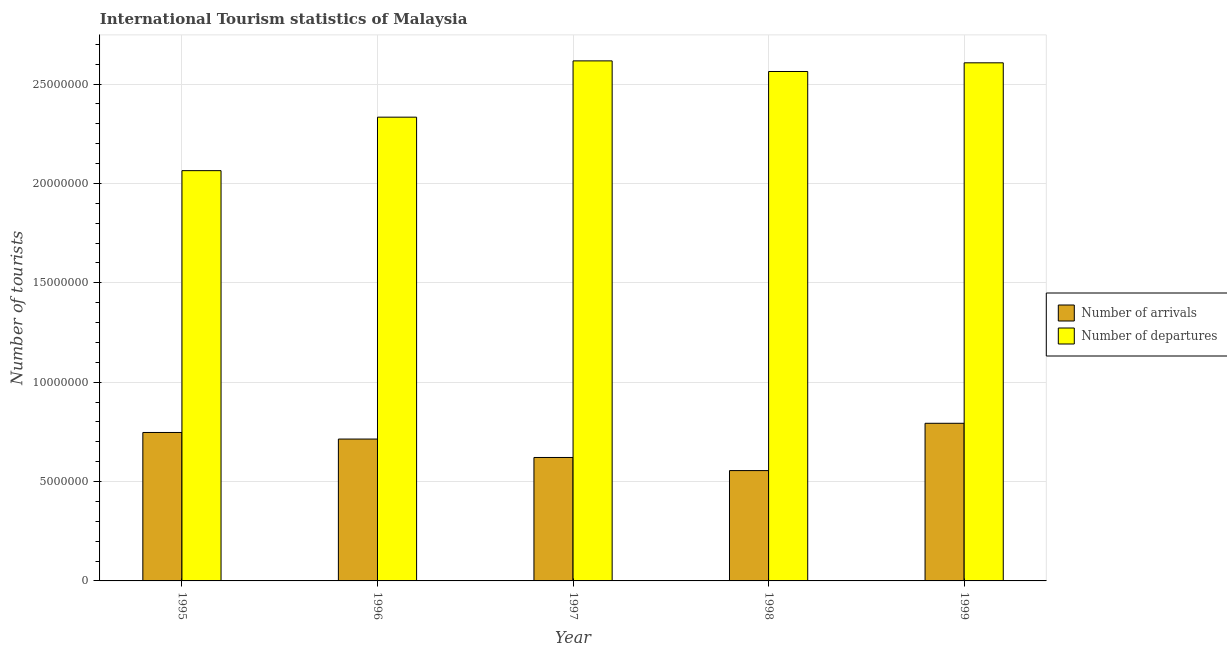How many different coloured bars are there?
Your answer should be very brief. 2. How many bars are there on the 4th tick from the right?
Provide a short and direct response. 2. What is the label of the 4th group of bars from the left?
Your response must be concise. 1998. In how many cases, is the number of bars for a given year not equal to the number of legend labels?
Give a very brief answer. 0. What is the number of tourist departures in 1996?
Your answer should be compact. 2.33e+07. Across all years, what is the maximum number of tourist departures?
Provide a short and direct response. 2.62e+07. Across all years, what is the minimum number of tourist arrivals?
Offer a terse response. 5.55e+06. What is the total number of tourist departures in the graph?
Give a very brief answer. 1.22e+08. What is the difference between the number of tourist departures in 1997 and that in 1998?
Your answer should be compact. 5.34e+05. What is the difference between the number of tourist arrivals in 1995 and the number of tourist departures in 1999?
Provide a succinct answer. -4.62e+05. What is the average number of tourist arrivals per year?
Your response must be concise. 6.86e+06. In the year 1999, what is the difference between the number of tourist arrivals and number of tourist departures?
Give a very brief answer. 0. In how many years, is the number of tourist arrivals greater than 15000000?
Your response must be concise. 0. What is the ratio of the number of tourist arrivals in 1995 to that in 1996?
Ensure brevity in your answer.  1.05. Is the difference between the number of tourist departures in 1995 and 1998 greater than the difference between the number of tourist arrivals in 1995 and 1998?
Give a very brief answer. No. What is the difference between the highest and the second highest number of tourist arrivals?
Offer a terse response. 4.62e+05. What is the difference between the highest and the lowest number of tourist arrivals?
Offer a terse response. 2.38e+06. Is the sum of the number of tourist departures in 1995 and 1998 greater than the maximum number of tourist arrivals across all years?
Provide a short and direct response. Yes. What does the 2nd bar from the left in 1996 represents?
Your answer should be compact. Number of departures. What does the 1st bar from the right in 1999 represents?
Keep it short and to the point. Number of departures. How many bars are there?
Your response must be concise. 10. Are the values on the major ticks of Y-axis written in scientific E-notation?
Your response must be concise. No. What is the title of the graph?
Offer a very short reply. International Tourism statistics of Malaysia. What is the label or title of the X-axis?
Give a very brief answer. Year. What is the label or title of the Y-axis?
Your answer should be compact. Number of tourists. What is the Number of tourists of Number of arrivals in 1995?
Ensure brevity in your answer.  7.47e+06. What is the Number of tourists in Number of departures in 1995?
Make the answer very short. 2.06e+07. What is the Number of tourists in Number of arrivals in 1996?
Provide a short and direct response. 7.14e+06. What is the Number of tourists in Number of departures in 1996?
Give a very brief answer. 2.33e+07. What is the Number of tourists in Number of arrivals in 1997?
Your response must be concise. 6.21e+06. What is the Number of tourists of Number of departures in 1997?
Offer a terse response. 2.62e+07. What is the Number of tourists in Number of arrivals in 1998?
Provide a short and direct response. 5.55e+06. What is the Number of tourists in Number of departures in 1998?
Your response must be concise. 2.56e+07. What is the Number of tourists in Number of arrivals in 1999?
Ensure brevity in your answer.  7.93e+06. What is the Number of tourists of Number of departures in 1999?
Give a very brief answer. 2.61e+07. Across all years, what is the maximum Number of tourists of Number of arrivals?
Provide a succinct answer. 7.93e+06. Across all years, what is the maximum Number of tourists of Number of departures?
Your response must be concise. 2.62e+07. Across all years, what is the minimum Number of tourists of Number of arrivals?
Keep it short and to the point. 5.55e+06. Across all years, what is the minimum Number of tourists of Number of departures?
Your answer should be very brief. 2.06e+07. What is the total Number of tourists of Number of arrivals in the graph?
Offer a very short reply. 3.43e+07. What is the total Number of tourists of Number of departures in the graph?
Make the answer very short. 1.22e+08. What is the difference between the Number of tourists of Number of arrivals in 1995 and that in 1996?
Your answer should be very brief. 3.31e+05. What is the difference between the Number of tourists in Number of departures in 1995 and that in 1996?
Provide a short and direct response. -2.69e+06. What is the difference between the Number of tourists in Number of arrivals in 1995 and that in 1997?
Make the answer very short. 1.26e+06. What is the difference between the Number of tourists in Number of departures in 1995 and that in 1997?
Offer a terse response. -5.52e+06. What is the difference between the Number of tourists in Number of arrivals in 1995 and that in 1998?
Ensure brevity in your answer.  1.92e+06. What is the difference between the Number of tourists in Number of departures in 1995 and that in 1998?
Your answer should be compact. -4.99e+06. What is the difference between the Number of tourists of Number of arrivals in 1995 and that in 1999?
Your response must be concise. -4.62e+05. What is the difference between the Number of tourists of Number of departures in 1995 and that in 1999?
Give a very brief answer. -5.42e+06. What is the difference between the Number of tourists in Number of arrivals in 1996 and that in 1997?
Offer a terse response. 9.27e+05. What is the difference between the Number of tourists in Number of departures in 1996 and that in 1997?
Keep it short and to the point. -2.83e+06. What is the difference between the Number of tourists in Number of arrivals in 1996 and that in 1998?
Make the answer very short. 1.59e+06. What is the difference between the Number of tourists in Number of departures in 1996 and that in 1998?
Provide a short and direct response. -2.30e+06. What is the difference between the Number of tourists in Number of arrivals in 1996 and that in 1999?
Provide a short and direct response. -7.93e+05. What is the difference between the Number of tourists of Number of departures in 1996 and that in 1999?
Make the answer very short. -2.73e+06. What is the difference between the Number of tourists of Number of arrivals in 1997 and that in 1998?
Provide a succinct answer. 6.60e+05. What is the difference between the Number of tourists in Number of departures in 1997 and that in 1998?
Give a very brief answer. 5.34e+05. What is the difference between the Number of tourists in Number of arrivals in 1997 and that in 1999?
Offer a very short reply. -1.72e+06. What is the difference between the Number of tourists of Number of departures in 1997 and that in 1999?
Ensure brevity in your answer.  9.80e+04. What is the difference between the Number of tourists of Number of arrivals in 1998 and that in 1999?
Offer a very short reply. -2.38e+06. What is the difference between the Number of tourists in Number of departures in 1998 and that in 1999?
Provide a succinct answer. -4.36e+05. What is the difference between the Number of tourists of Number of arrivals in 1995 and the Number of tourists of Number of departures in 1996?
Give a very brief answer. -1.59e+07. What is the difference between the Number of tourists in Number of arrivals in 1995 and the Number of tourists in Number of departures in 1997?
Offer a terse response. -1.87e+07. What is the difference between the Number of tourists in Number of arrivals in 1995 and the Number of tourists in Number of departures in 1998?
Offer a very short reply. -1.82e+07. What is the difference between the Number of tourists of Number of arrivals in 1995 and the Number of tourists of Number of departures in 1999?
Ensure brevity in your answer.  -1.86e+07. What is the difference between the Number of tourists of Number of arrivals in 1996 and the Number of tourists of Number of departures in 1997?
Your answer should be compact. -1.90e+07. What is the difference between the Number of tourists in Number of arrivals in 1996 and the Number of tourists in Number of departures in 1998?
Your response must be concise. -1.85e+07. What is the difference between the Number of tourists in Number of arrivals in 1996 and the Number of tourists in Number of departures in 1999?
Provide a short and direct response. -1.89e+07. What is the difference between the Number of tourists of Number of arrivals in 1997 and the Number of tourists of Number of departures in 1998?
Your answer should be compact. -1.94e+07. What is the difference between the Number of tourists of Number of arrivals in 1997 and the Number of tourists of Number of departures in 1999?
Ensure brevity in your answer.  -1.99e+07. What is the difference between the Number of tourists in Number of arrivals in 1998 and the Number of tourists in Number of departures in 1999?
Make the answer very short. -2.05e+07. What is the average Number of tourists of Number of arrivals per year?
Keep it short and to the point. 6.86e+06. What is the average Number of tourists of Number of departures per year?
Offer a terse response. 2.44e+07. In the year 1995, what is the difference between the Number of tourists of Number of arrivals and Number of tourists of Number of departures?
Provide a short and direct response. -1.32e+07. In the year 1996, what is the difference between the Number of tourists in Number of arrivals and Number of tourists in Number of departures?
Give a very brief answer. -1.62e+07. In the year 1997, what is the difference between the Number of tourists in Number of arrivals and Number of tourists in Number of departures?
Your answer should be very brief. -2.00e+07. In the year 1998, what is the difference between the Number of tourists of Number of arrivals and Number of tourists of Number of departures?
Your answer should be compact. -2.01e+07. In the year 1999, what is the difference between the Number of tourists of Number of arrivals and Number of tourists of Number of departures?
Provide a short and direct response. -1.81e+07. What is the ratio of the Number of tourists in Number of arrivals in 1995 to that in 1996?
Offer a very short reply. 1.05. What is the ratio of the Number of tourists of Number of departures in 1995 to that in 1996?
Your answer should be compact. 0.88. What is the ratio of the Number of tourists of Number of arrivals in 1995 to that in 1997?
Offer a terse response. 1.2. What is the ratio of the Number of tourists in Number of departures in 1995 to that in 1997?
Offer a very short reply. 0.79. What is the ratio of the Number of tourists of Number of arrivals in 1995 to that in 1998?
Offer a terse response. 1.35. What is the ratio of the Number of tourists of Number of departures in 1995 to that in 1998?
Keep it short and to the point. 0.81. What is the ratio of the Number of tourists of Number of arrivals in 1995 to that in 1999?
Your answer should be very brief. 0.94. What is the ratio of the Number of tourists of Number of departures in 1995 to that in 1999?
Ensure brevity in your answer.  0.79. What is the ratio of the Number of tourists in Number of arrivals in 1996 to that in 1997?
Make the answer very short. 1.15. What is the ratio of the Number of tourists in Number of departures in 1996 to that in 1997?
Give a very brief answer. 0.89. What is the ratio of the Number of tourists of Number of arrivals in 1996 to that in 1998?
Your response must be concise. 1.29. What is the ratio of the Number of tourists in Number of departures in 1996 to that in 1998?
Keep it short and to the point. 0.91. What is the ratio of the Number of tourists of Number of departures in 1996 to that in 1999?
Your answer should be very brief. 0.9. What is the ratio of the Number of tourists in Number of arrivals in 1997 to that in 1998?
Provide a succinct answer. 1.12. What is the ratio of the Number of tourists in Number of departures in 1997 to that in 1998?
Provide a short and direct response. 1.02. What is the ratio of the Number of tourists in Number of arrivals in 1997 to that in 1999?
Provide a succinct answer. 0.78. What is the ratio of the Number of tourists in Number of departures in 1997 to that in 1999?
Offer a terse response. 1. What is the ratio of the Number of tourists in Number of arrivals in 1998 to that in 1999?
Your answer should be compact. 0.7. What is the ratio of the Number of tourists of Number of departures in 1998 to that in 1999?
Your answer should be very brief. 0.98. What is the difference between the highest and the second highest Number of tourists in Number of arrivals?
Make the answer very short. 4.62e+05. What is the difference between the highest and the second highest Number of tourists in Number of departures?
Your response must be concise. 9.80e+04. What is the difference between the highest and the lowest Number of tourists in Number of arrivals?
Offer a terse response. 2.38e+06. What is the difference between the highest and the lowest Number of tourists of Number of departures?
Provide a short and direct response. 5.52e+06. 